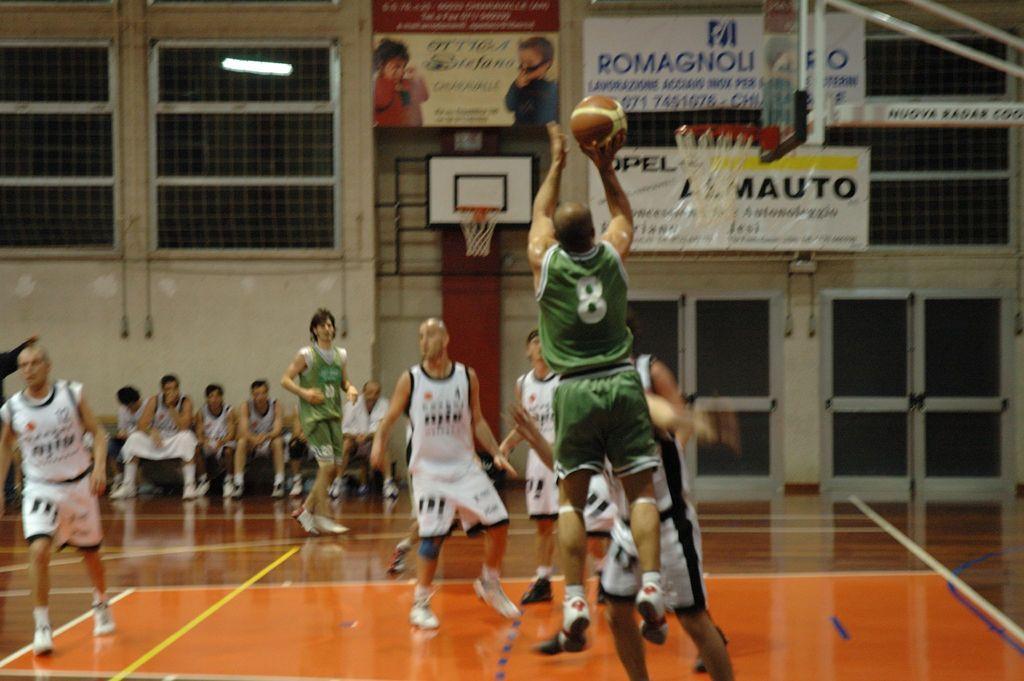Could you give a brief overview of what you see in this image? In this image I see number of men in which these men are sitting over here and I see that all of them are wearing jerseys and I see that this man is holding a ball and I see the basketball court. In the background I see the wall and I see boards over here on which something is written and I see the basket over here and I see the light over here. 